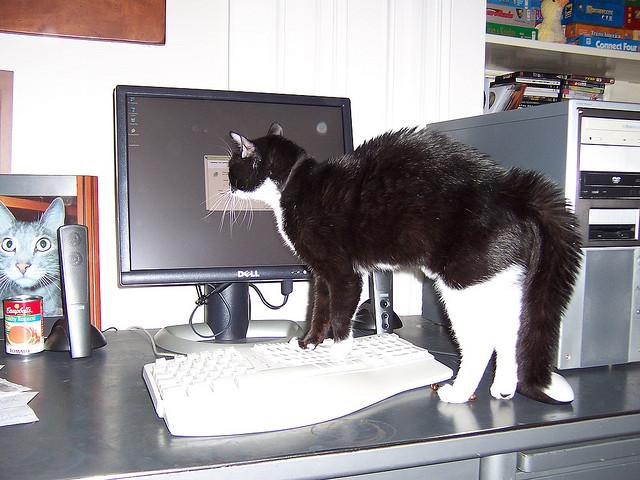Does the cat know what's on the screen?
Quick response, please. No. What color is the cat?
Answer briefly. Black and white. What kind of soup do they like?
Answer briefly. Campbell's. 